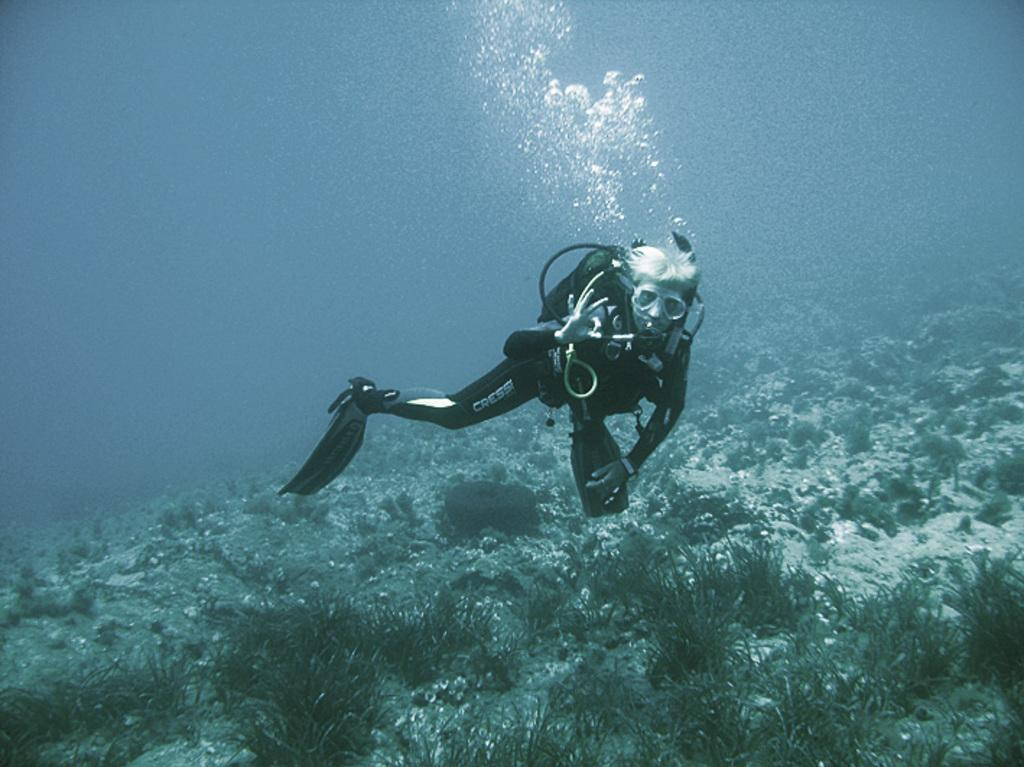Who is in the image? There is a person in the image. What is the person wearing? The person is wearing swim fins. What equipment does the person have? The person has an oxygen cylinder. What can be seen under the water in the image? There are plants and rocks visible under the water. How many pigs are swimming with the person in the image? There are no pigs present in the image. Can you tell me the color of the yak in the image? There is no yak present in the image. 